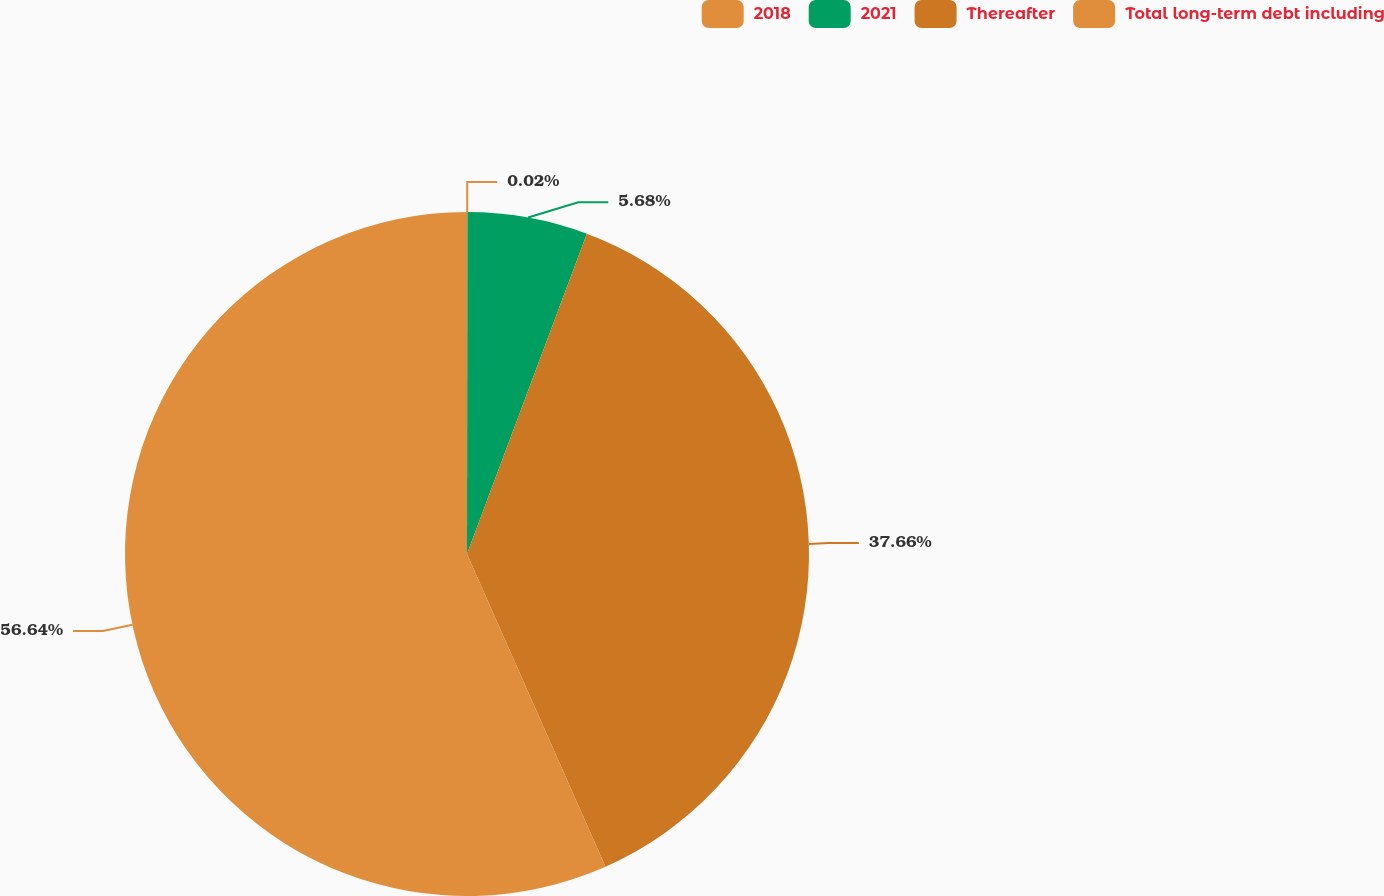Convert chart. <chart><loc_0><loc_0><loc_500><loc_500><pie_chart><fcel>2018<fcel>2021<fcel>Thereafter<fcel>Total long-term debt including<nl><fcel>0.02%<fcel>5.68%<fcel>37.66%<fcel>56.63%<nl></chart> 